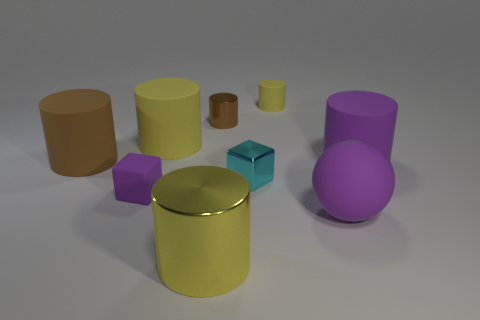Subtract all brown spheres. How many yellow cylinders are left? 3 Subtract 1 cylinders. How many cylinders are left? 5 Subtract all purple cylinders. How many cylinders are left? 5 Subtract all purple cylinders. How many cylinders are left? 5 Subtract all cyan cylinders. Subtract all gray balls. How many cylinders are left? 6 Add 1 big things. How many objects exist? 10 Subtract all spheres. How many objects are left? 8 Add 3 yellow cylinders. How many yellow cylinders are left? 6 Add 6 small yellow things. How many small yellow things exist? 7 Subtract 0 yellow blocks. How many objects are left? 9 